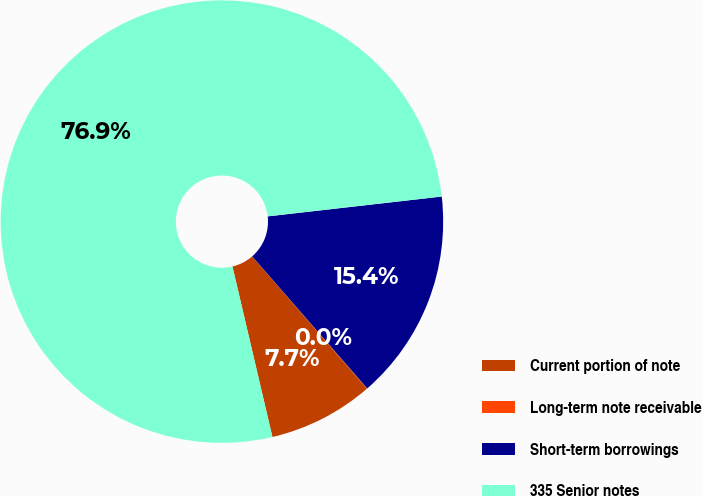Convert chart. <chart><loc_0><loc_0><loc_500><loc_500><pie_chart><fcel>Current portion of note<fcel>Long-term note receivable<fcel>Short-term borrowings<fcel>335 Senior notes<nl><fcel>7.71%<fcel>0.03%<fcel>15.4%<fcel>76.86%<nl></chart> 